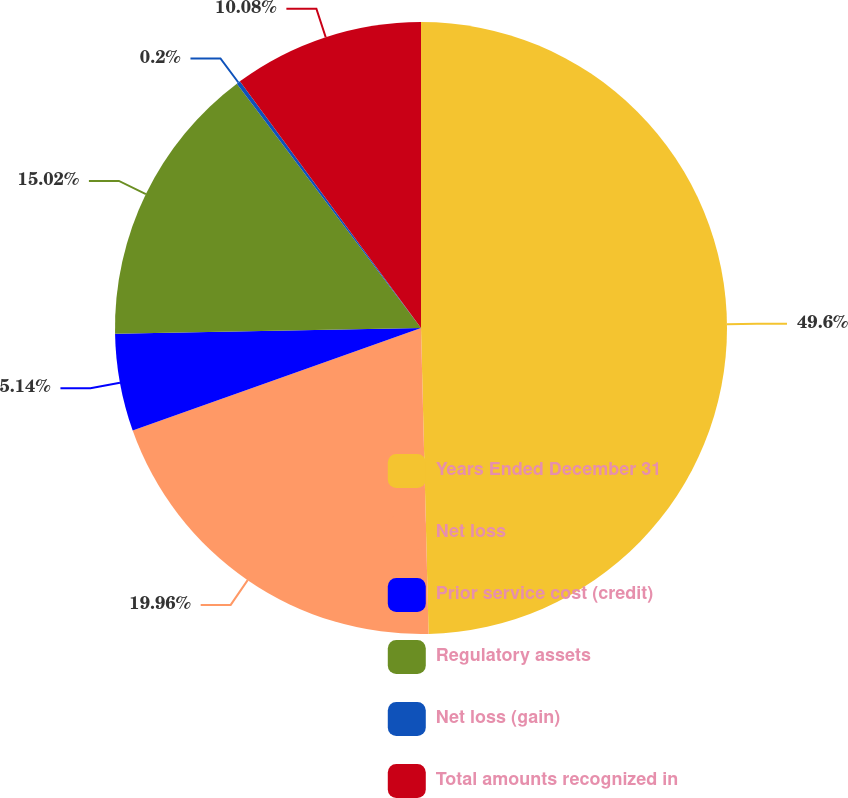Convert chart to OTSL. <chart><loc_0><loc_0><loc_500><loc_500><pie_chart><fcel>Years Ended December 31<fcel>Net loss<fcel>Prior service cost (credit)<fcel>Regulatory assets<fcel>Net loss (gain)<fcel>Total amounts recognized in<nl><fcel>49.61%<fcel>19.96%<fcel>5.14%<fcel>15.02%<fcel>0.2%<fcel>10.08%<nl></chart> 